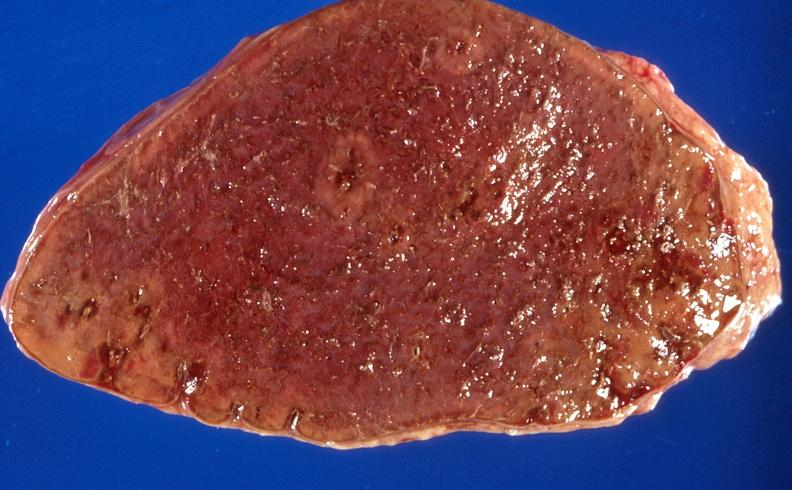does this image show sickle cell disease, spleen?
Answer the question using a single word or phrase. Yes 